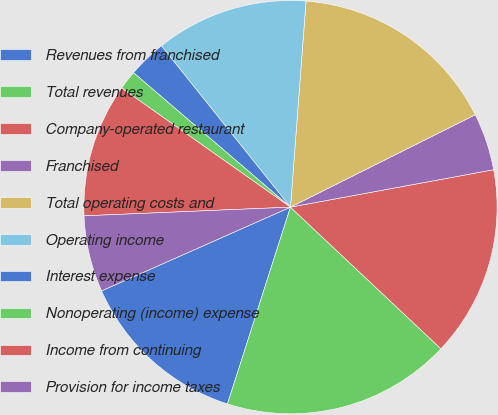<chart> <loc_0><loc_0><loc_500><loc_500><pie_chart><fcel>Revenues from franchised<fcel>Total revenues<fcel>Company-operated restaurant<fcel>Franchised<fcel>Total operating costs and<fcel>Operating income<fcel>Interest expense<fcel>Nonoperating (income) expense<fcel>Income from continuing<fcel>Provision for income taxes<nl><fcel>13.43%<fcel>17.91%<fcel>14.92%<fcel>4.48%<fcel>16.42%<fcel>11.94%<fcel>2.99%<fcel>1.49%<fcel>10.45%<fcel>5.97%<nl></chart> 